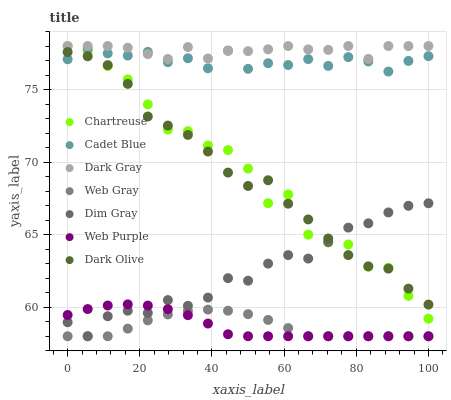Does Web Gray have the minimum area under the curve?
Answer yes or no. Yes. Does Dark Gray have the maximum area under the curve?
Answer yes or no. Yes. Does Dim Gray have the minimum area under the curve?
Answer yes or no. No. Does Dim Gray have the maximum area under the curve?
Answer yes or no. No. Is Web Purple the smoothest?
Answer yes or no. Yes. Is Chartreuse the roughest?
Answer yes or no. Yes. Is Dim Gray the smoothest?
Answer yes or no. No. Is Dim Gray the roughest?
Answer yes or no. No. Does Dim Gray have the lowest value?
Answer yes or no. Yes. Does Dark Olive have the lowest value?
Answer yes or no. No. Does Chartreuse have the highest value?
Answer yes or no. Yes. Does Dim Gray have the highest value?
Answer yes or no. No. Is Web Purple less than Cadet Blue?
Answer yes or no. Yes. Is Cadet Blue greater than Web Gray?
Answer yes or no. Yes. Does Web Purple intersect Dim Gray?
Answer yes or no. Yes. Is Web Purple less than Dim Gray?
Answer yes or no. No. Is Web Purple greater than Dim Gray?
Answer yes or no. No. Does Web Purple intersect Cadet Blue?
Answer yes or no. No. 